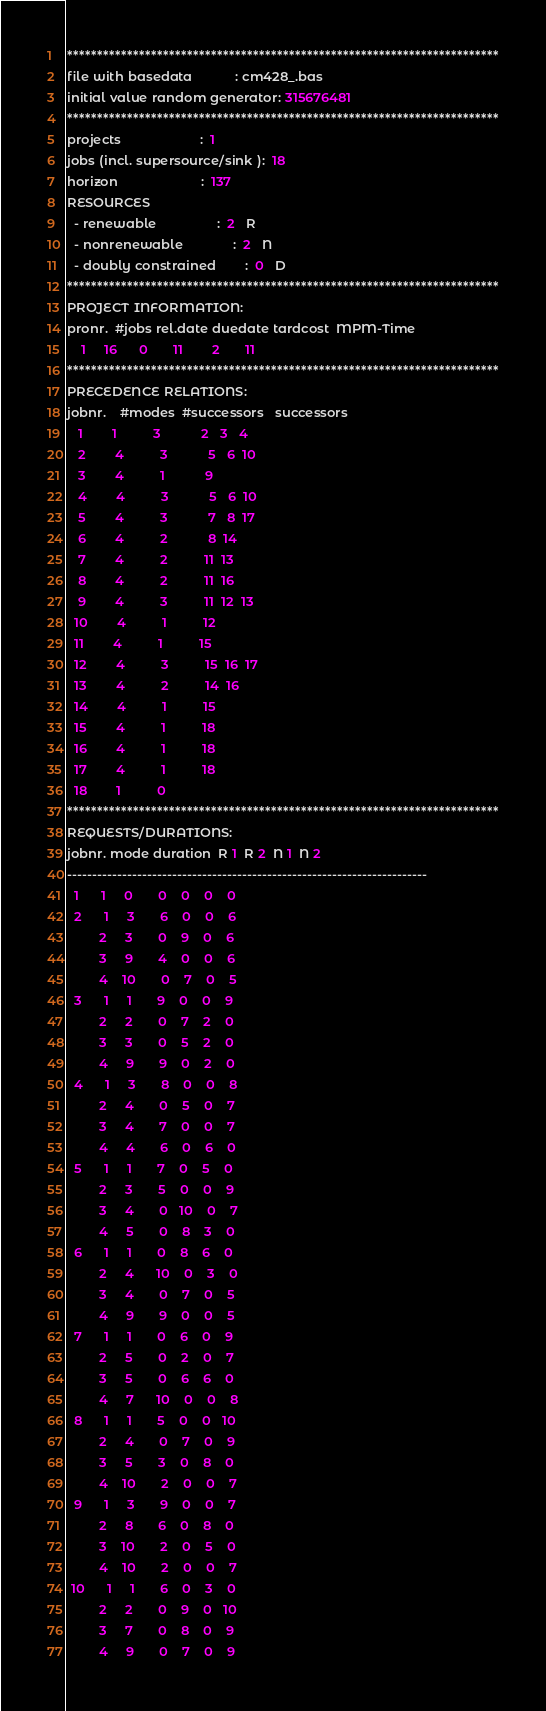Convert code to text. <code><loc_0><loc_0><loc_500><loc_500><_ObjectiveC_>************************************************************************
file with basedata            : cm428_.bas
initial value random generator: 315676481
************************************************************************
projects                      :  1
jobs (incl. supersource/sink ):  18
horizon                       :  137
RESOURCES
  - renewable                 :  2   R
  - nonrenewable              :  2   N
  - doubly constrained        :  0   D
************************************************************************
PROJECT INFORMATION:
pronr.  #jobs rel.date duedate tardcost  MPM-Time
    1     16      0       11        2       11
************************************************************************
PRECEDENCE RELATIONS:
jobnr.    #modes  #successors   successors
   1        1          3           2   3   4
   2        4          3           5   6  10
   3        4          1           9
   4        4          3           5   6  10
   5        4          3           7   8  17
   6        4          2           8  14
   7        4          2          11  13
   8        4          2          11  16
   9        4          3          11  12  13
  10        4          1          12
  11        4          1          15
  12        4          3          15  16  17
  13        4          2          14  16
  14        4          1          15
  15        4          1          18
  16        4          1          18
  17        4          1          18
  18        1          0        
************************************************************************
REQUESTS/DURATIONS:
jobnr. mode duration  R 1  R 2  N 1  N 2
------------------------------------------------------------------------
  1      1     0       0    0    0    0
  2      1     3       6    0    0    6
         2     3       0    9    0    6
         3     9       4    0    0    6
         4    10       0    7    0    5
  3      1     1       9    0    0    9
         2     2       0    7    2    0
         3     3       0    5    2    0
         4     9       9    0    2    0
  4      1     3       8    0    0    8
         2     4       0    5    0    7
         3     4       7    0    0    7
         4     4       6    0    6    0
  5      1     1       7    0    5    0
         2     3       5    0    0    9
         3     4       0   10    0    7
         4     5       0    8    3    0
  6      1     1       0    8    6    0
         2     4      10    0    3    0
         3     4       0    7    0    5
         4     9       9    0    0    5
  7      1     1       0    6    0    9
         2     5       0    2    0    7
         3     5       0    6    6    0
         4     7      10    0    0    8
  8      1     1       5    0    0   10
         2     4       0    7    0    9
         3     5       3    0    8    0
         4    10       2    0    0    7
  9      1     3       9    0    0    7
         2     8       6    0    8    0
         3    10       2    0    5    0
         4    10       2    0    0    7
 10      1     1       6    0    3    0
         2     2       0    9    0   10
         3     7       0    8    0    9
         4     9       0    7    0    9</code> 